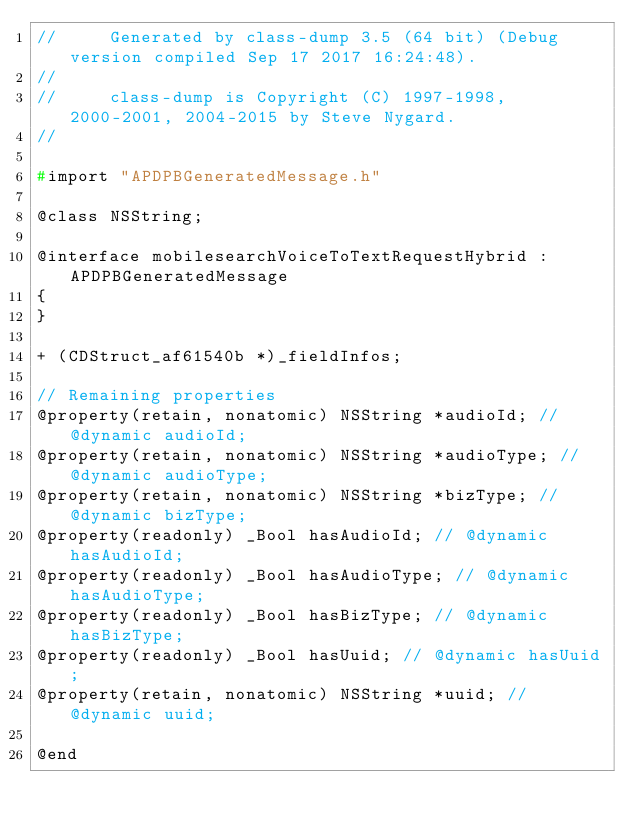<code> <loc_0><loc_0><loc_500><loc_500><_C_>//     Generated by class-dump 3.5 (64 bit) (Debug version compiled Sep 17 2017 16:24:48).
//
//     class-dump is Copyright (C) 1997-1998, 2000-2001, 2004-2015 by Steve Nygard.
//

#import "APDPBGeneratedMessage.h"

@class NSString;

@interface mobilesearchVoiceToTextRequestHybrid : APDPBGeneratedMessage
{
}

+ (CDStruct_af61540b *)_fieldInfos;

// Remaining properties
@property(retain, nonatomic) NSString *audioId; // @dynamic audioId;
@property(retain, nonatomic) NSString *audioType; // @dynamic audioType;
@property(retain, nonatomic) NSString *bizType; // @dynamic bizType;
@property(readonly) _Bool hasAudioId; // @dynamic hasAudioId;
@property(readonly) _Bool hasAudioType; // @dynamic hasAudioType;
@property(readonly) _Bool hasBizType; // @dynamic hasBizType;
@property(readonly) _Bool hasUuid; // @dynamic hasUuid;
@property(retain, nonatomic) NSString *uuid; // @dynamic uuid;

@end

</code> 